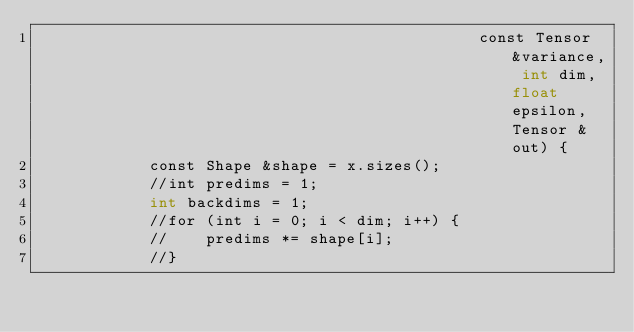<code> <loc_0><loc_0><loc_500><loc_500><_Cuda_>                                               const Tensor &variance, int dim, float epsilon, Tensor &out) {
            const Shape &shape = x.sizes();
            //int predims = 1;
            int backdims = 1;
            //for (int i = 0; i < dim; i++) {
            //    predims *= shape[i];
            //}
</code> 